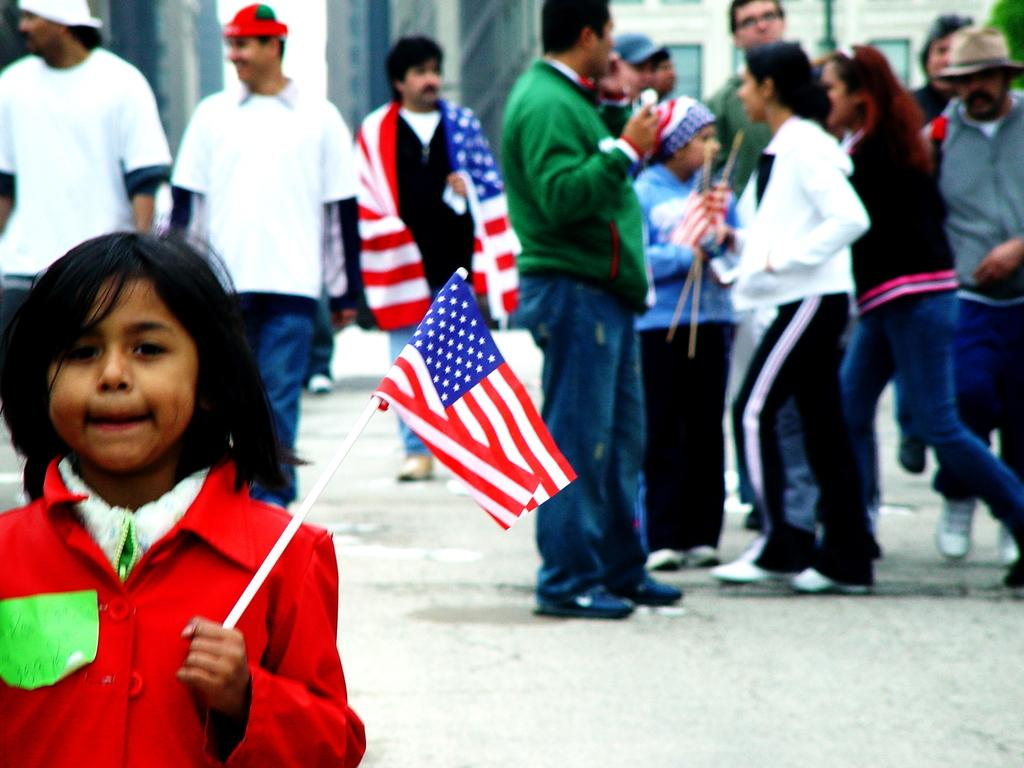Who or what can be seen in the image? There are people in the image. What is the girl holding in the image? The girl is holding a flag with a stick. Can you describe the background of the image? The background of the image is blurry. What news can be heard coming from the seashore in the image? There is no reference to news or a seashore in the image, so it's not possible to determine what news might be heard. 